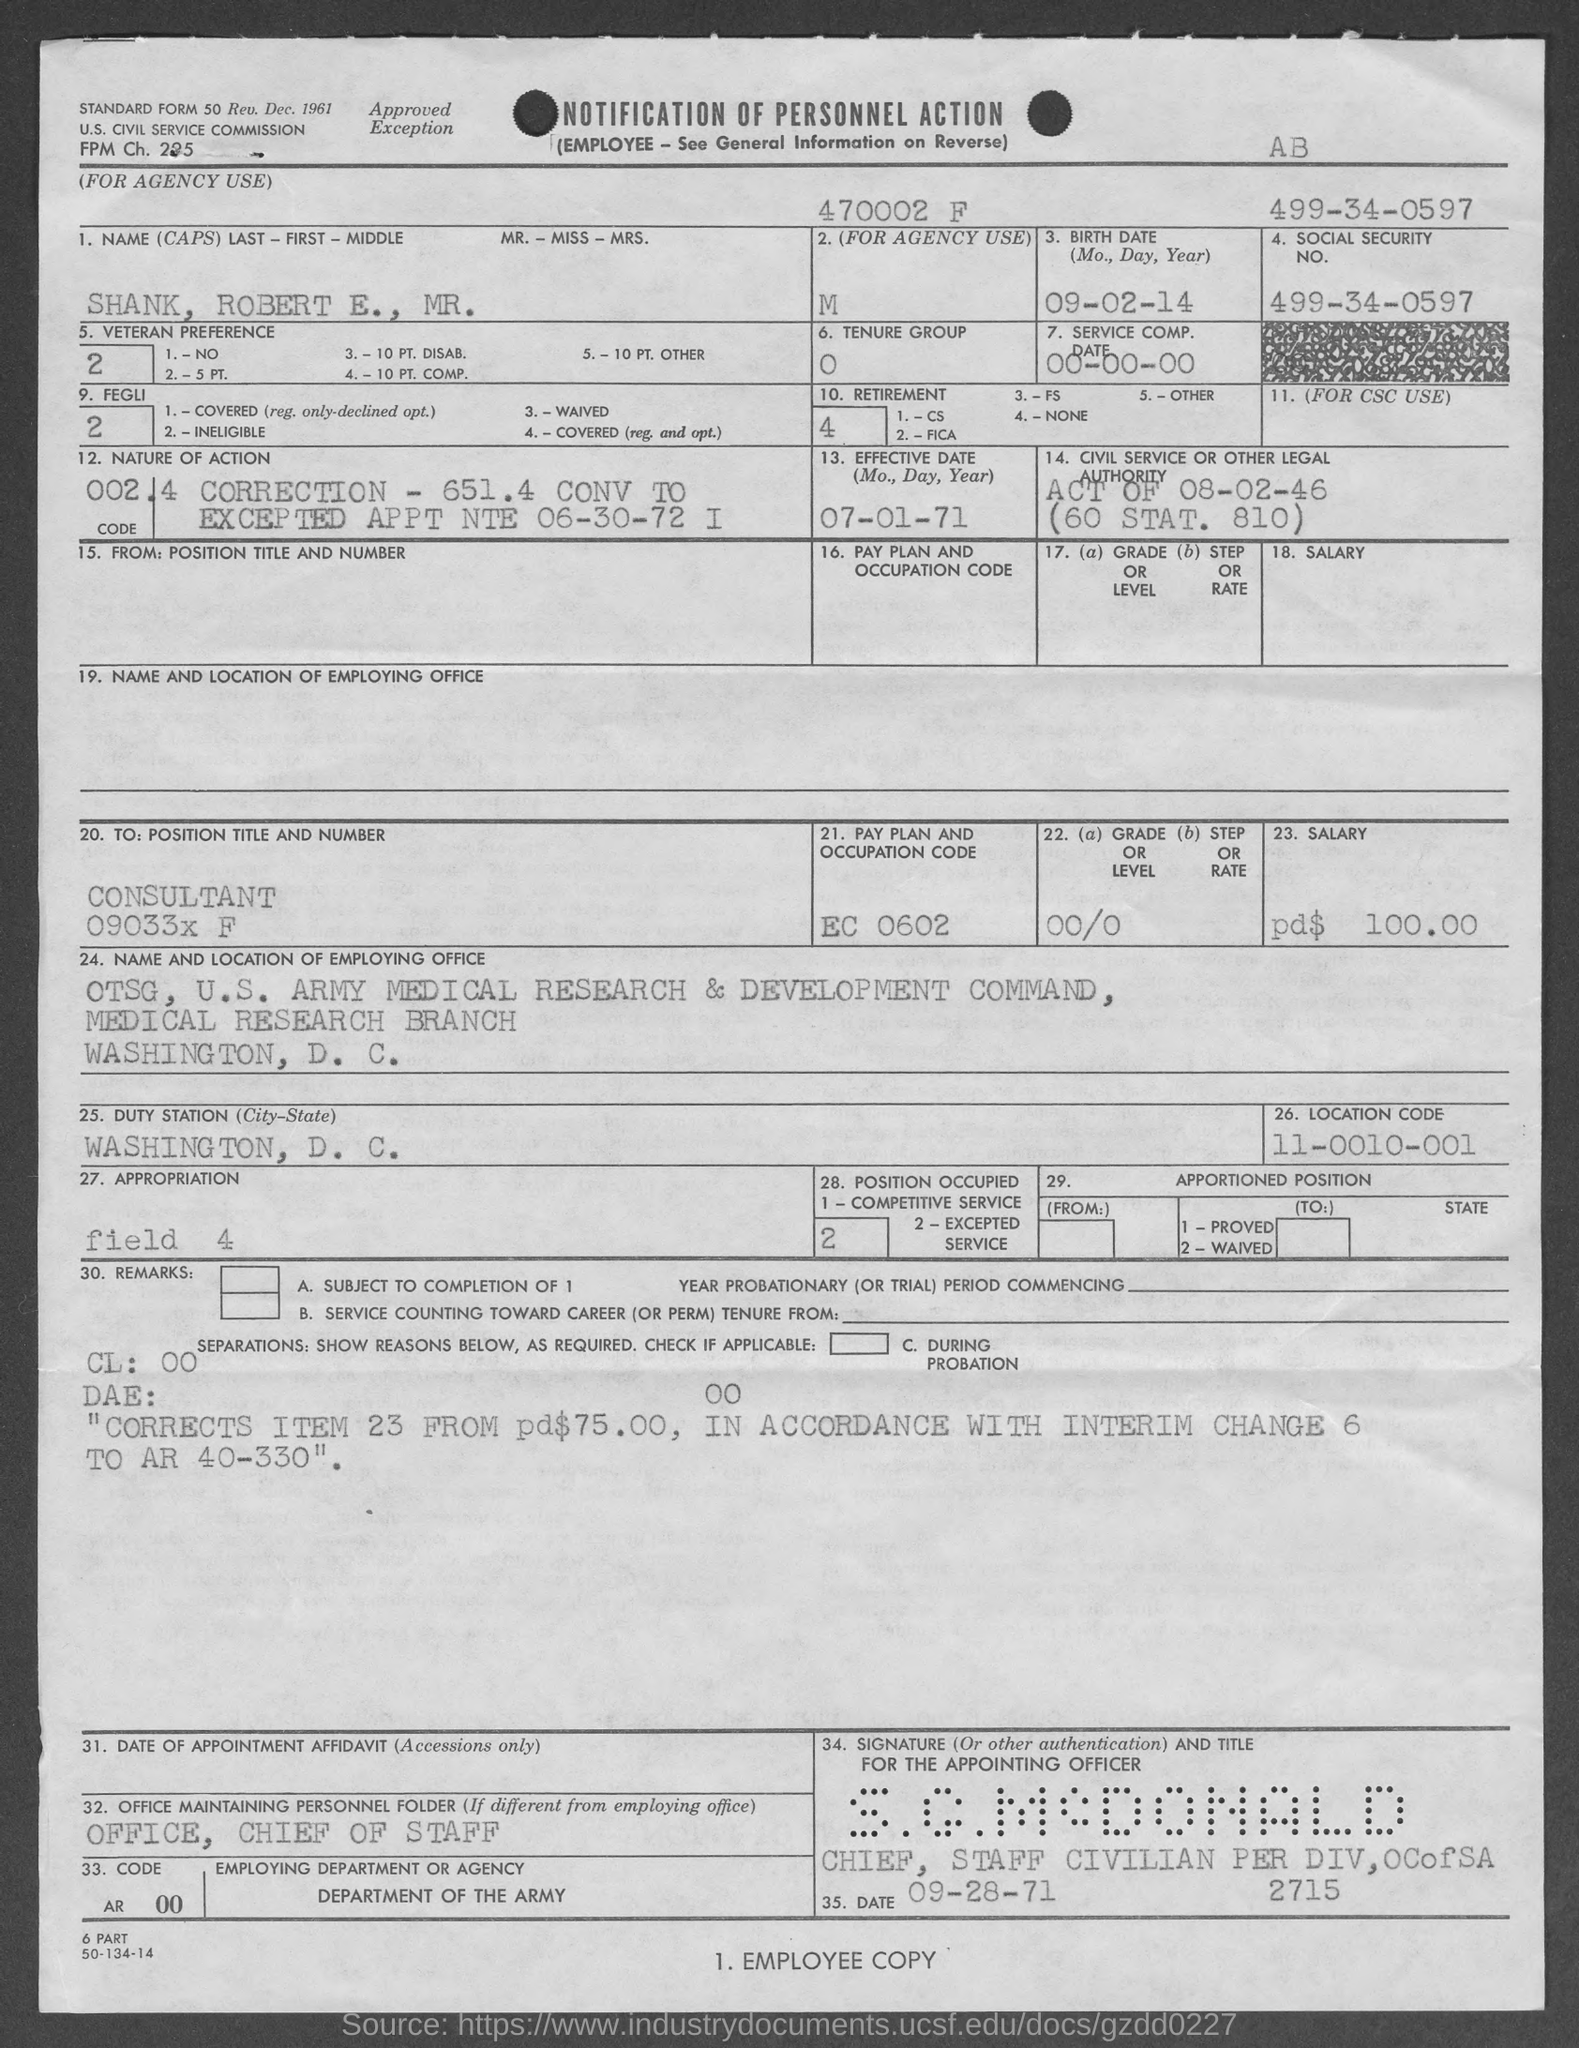Point out several critical features in this image. Please provide the location code, which is 11-0010-001... The birth date of the candidate is September 2, 2014. The Social Security number is 499-34-0597. The pay plan and occupation code for EC 0602 is [insert information here]. 